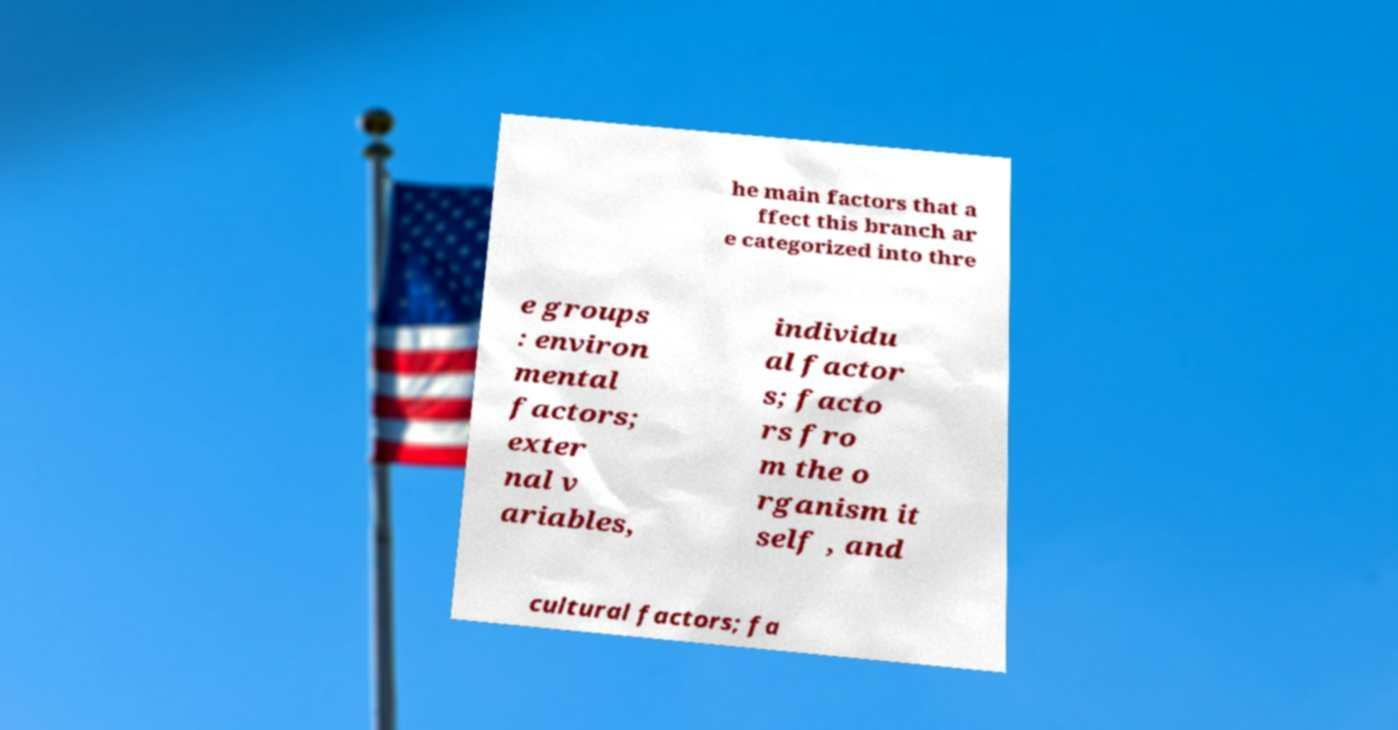Please identify and transcribe the text found in this image. he main factors that a ffect this branch ar e categorized into thre e groups : environ mental factors; exter nal v ariables, individu al factor s; facto rs fro m the o rganism it self , and cultural factors; fa 